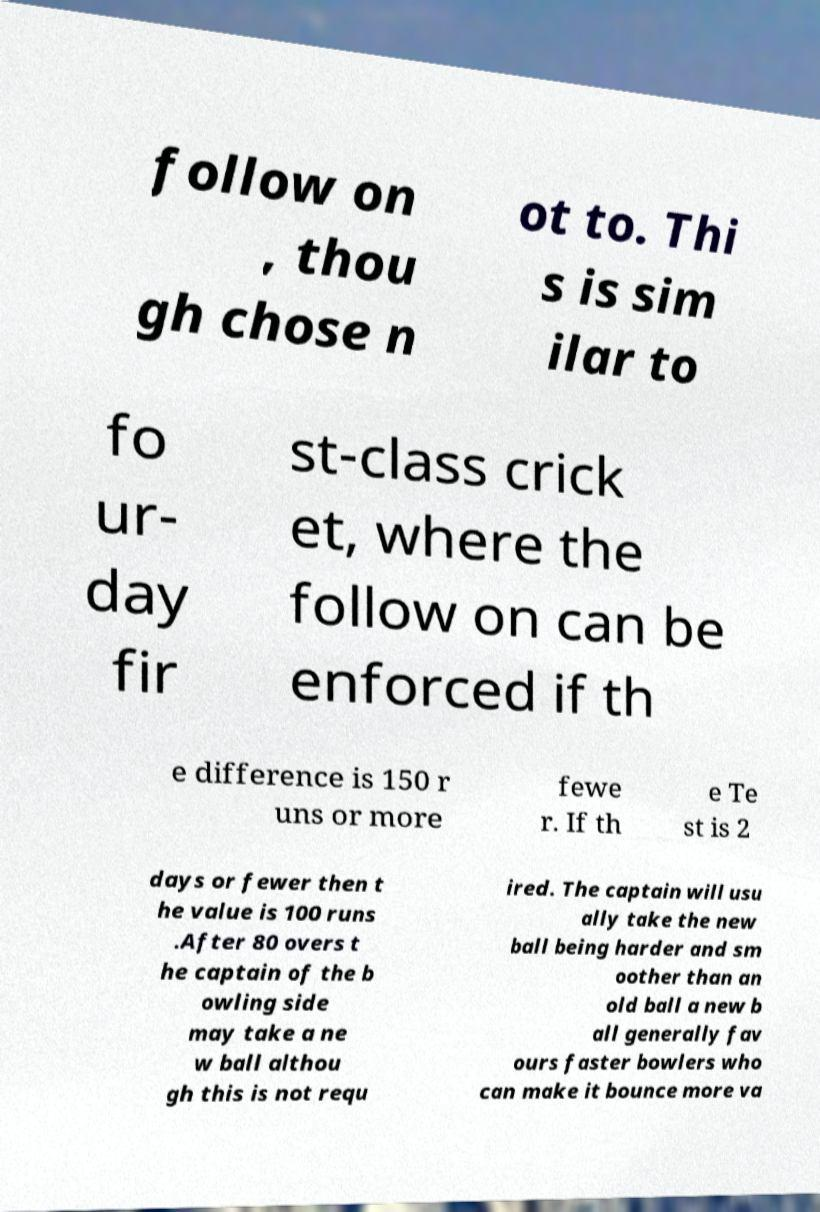Please identify and transcribe the text found in this image. follow on , thou gh chose n ot to. Thi s is sim ilar to fo ur- day fir st-class crick et, where the follow on can be enforced if th e difference is 150 r uns or more fewe r. If th e Te st is 2 days or fewer then t he value is 100 runs .After 80 overs t he captain of the b owling side may take a ne w ball althou gh this is not requ ired. The captain will usu ally take the new ball being harder and sm oother than an old ball a new b all generally fav ours faster bowlers who can make it bounce more va 